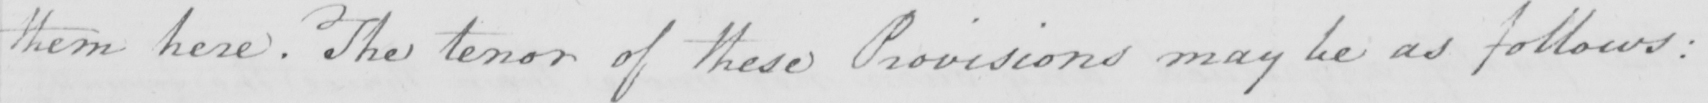Can you read and transcribe this handwriting? them here . The tenor of these Provisions may be as follows : 